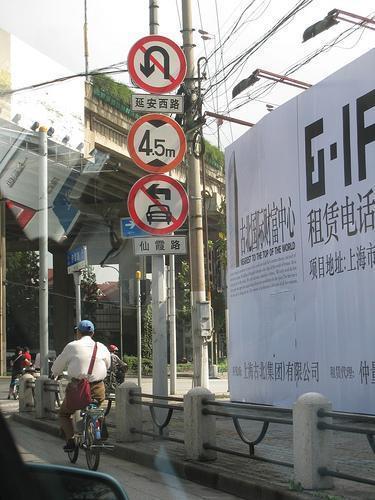How many "do not U turn" signs are there in this picture?
Give a very brief answer. 1. How many people are visible?
Give a very brief answer. 1. How many cars can you see?
Give a very brief answer. 1. How many dogs are looking at the camers?
Give a very brief answer. 0. 